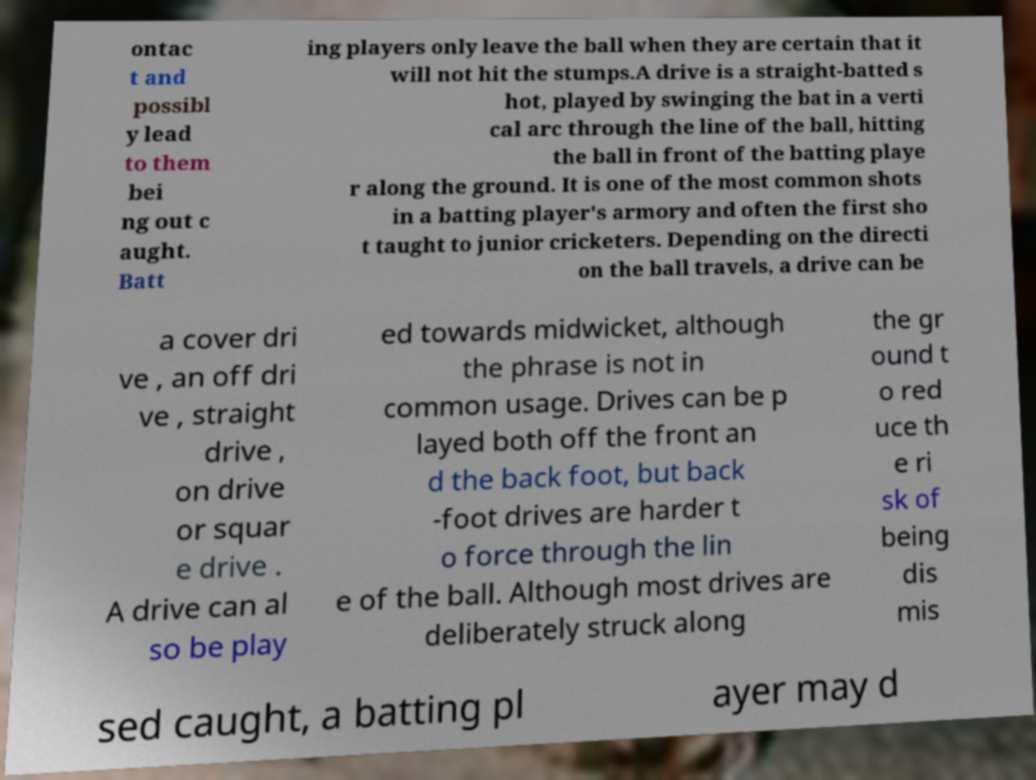For documentation purposes, I need the text within this image transcribed. Could you provide that? ontac t and possibl y lead to them bei ng out c aught. Batt ing players only leave the ball when they are certain that it will not hit the stumps.A drive is a straight-batted s hot, played by swinging the bat in a verti cal arc through the line of the ball, hitting the ball in front of the batting playe r along the ground. It is one of the most common shots in a batting player's armory and often the first sho t taught to junior cricketers. Depending on the directi on the ball travels, a drive can be a cover dri ve , an off dri ve , straight drive , on drive or squar e drive . A drive can al so be play ed towards midwicket, although the phrase is not in common usage. Drives can be p layed both off the front an d the back foot, but back -foot drives are harder t o force through the lin e of the ball. Although most drives are deliberately struck along the gr ound t o red uce th e ri sk of being dis mis sed caught, a batting pl ayer may d 